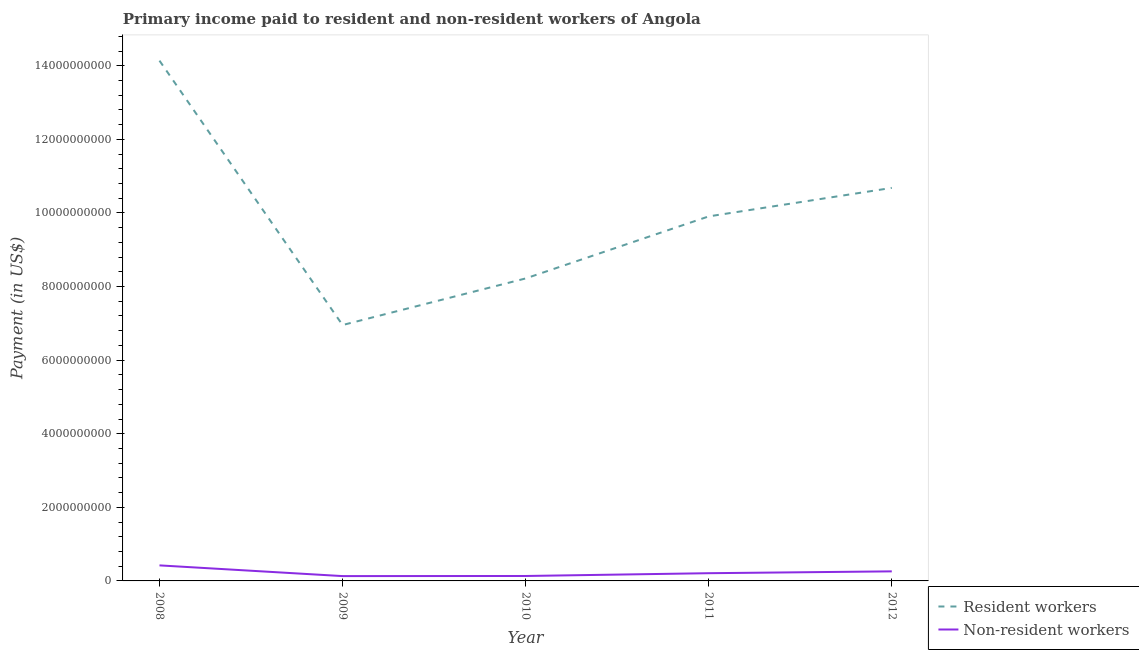How many different coloured lines are there?
Your answer should be very brief. 2. Does the line corresponding to payment made to resident workers intersect with the line corresponding to payment made to non-resident workers?
Make the answer very short. No. Is the number of lines equal to the number of legend labels?
Keep it short and to the point. Yes. What is the payment made to resident workers in 2011?
Give a very brief answer. 9.91e+09. Across all years, what is the maximum payment made to resident workers?
Provide a succinct answer. 1.41e+1. Across all years, what is the minimum payment made to non-resident workers?
Provide a short and direct response. 1.31e+08. In which year was the payment made to non-resident workers maximum?
Give a very brief answer. 2008. What is the total payment made to resident workers in the graph?
Keep it short and to the point. 4.99e+1. What is the difference between the payment made to resident workers in 2010 and that in 2012?
Your response must be concise. -2.46e+09. What is the difference between the payment made to resident workers in 2012 and the payment made to non-resident workers in 2008?
Provide a succinct answer. 1.03e+1. What is the average payment made to resident workers per year?
Provide a short and direct response. 9.98e+09. In the year 2008, what is the difference between the payment made to resident workers and payment made to non-resident workers?
Ensure brevity in your answer.  1.37e+1. In how many years, is the payment made to resident workers greater than 7600000000 US$?
Make the answer very short. 4. What is the ratio of the payment made to resident workers in 2008 to that in 2009?
Provide a short and direct response. 2.03. Is the difference between the payment made to non-resident workers in 2009 and 2012 greater than the difference between the payment made to resident workers in 2009 and 2012?
Your answer should be very brief. Yes. What is the difference between the highest and the second highest payment made to resident workers?
Keep it short and to the point. 3.46e+09. What is the difference between the highest and the lowest payment made to resident workers?
Ensure brevity in your answer.  7.19e+09. In how many years, is the payment made to resident workers greater than the average payment made to resident workers taken over all years?
Your response must be concise. 2. Is the sum of the payment made to non-resident workers in 2010 and 2011 greater than the maximum payment made to resident workers across all years?
Provide a succinct answer. No. What is the difference between two consecutive major ticks on the Y-axis?
Provide a succinct answer. 2.00e+09. Are the values on the major ticks of Y-axis written in scientific E-notation?
Provide a succinct answer. No. Does the graph contain grids?
Provide a short and direct response. No. Where does the legend appear in the graph?
Ensure brevity in your answer.  Bottom right. How are the legend labels stacked?
Provide a short and direct response. Vertical. What is the title of the graph?
Your answer should be very brief. Primary income paid to resident and non-resident workers of Angola. Does "Merchandise exports" appear as one of the legend labels in the graph?
Your response must be concise. No. What is the label or title of the X-axis?
Offer a very short reply. Year. What is the label or title of the Y-axis?
Offer a terse response. Payment (in US$). What is the Payment (in US$) of Resident workers in 2008?
Your answer should be compact. 1.41e+1. What is the Payment (in US$) in Non-resident workers in 2008?
Provide a succinct answer. 4.22e+08. What is the Payment (in US$) in Resident workers in 2009?
Provide a short and direct response. 6.95e+09. What is the Payment (in US$) in Non-resident workers in 2009?
Provide a short and direct response. 1.31e+08. What is the Payment (in US$) of Resident workers in 2010?
Your answer should be compact. 8.22e+09. What is the Payment (in US$) in Non-resident workers in 2010?
Offer a very short reply. 1.34e+08. What is the Payment (in US$) of Resident workers in 2011?
Ensure brevity in your answer.  9.91e+09. What is the Payment (in US$) in Non-resident workers in 2011?
Your answer should be very brief. 2.10e+08. What is the Payment (in US$) of Resident workers in 2012?
Keep it short and to the point. 1.07e+1. What is the Payment (in US$) of Non-resident workers in 2012?
Offer a very short reply. 2.60e+08. Across all years, what is the maximum Payment (in US$) of Resident workers?
Your response must be concise. 1.41e+1. Across all years, what is the maximum Payment (in US$) of Non-resident workers?
Provide a succinct answer. 4.22e+08. Across all years, what is the minimum Payment (in US$) of Resident workers?
Your answer should be very brief. 6.95e+09. Across all years, what is the minimum Payment (in US$) in Non-resident workers?
Offer a very short reply. 1.31e+08. What is the total Payment (in US$) of Resident workers in the graph?
Your answer should be very brief. 4.99e+1. What is the total Payment (in US$) in Non-resident workers in the graph?
Keep it short and to the point. 1.16e+09. What is the difference between the Payment (in US$) of Resident workers in 2008 and that in 2009?
Provide a succinct answer. 7.19e+09. What is the difference between the Payment (in US$) of Non-resident workers in 2008 and that in 2009?
Offer a terse response. 2.91e+08. What is the difference between the Payment (in US$) in Resident workers in 2008 and that in 2010?
Your response must be concise. 5.92e+09. What is the difference between the Payment (in US$) of Non-resident workers in 2008 and that in 2010?
Your response must be concise. 2.88e+08. What is the difference between the Payment (in US$) in Resident workers in 2008 and that in 2011?
Provide a short and direct response. 4.23e+09. What is the difference between the Payment (in US$) in Non-resident workers in 2008 and that in 2011?
Give a very brief answer. 2.12e+08. What is the difference between the Payment (in US$) in Resident workers in 2008 and that in 2012?
Give a very brief answer. 3.46e+09. What is the difference between the Payment (in US$) in Non-resident workers in 2008 and that in 2012?
Make the answer very short. 1.62e+08. What is the difference between the Payment (in US$) of Resident workers in 2009 and that in 2010?
Provide a succinct answer. -1.27e+09. What is the difference between the Payment (in US$) in Non-resident workers in 2009 and that in 2010?
Provide a short and direct response. -2.70e+06. What is the difference between the Payment (in US$) of Resident workers in 2009 and that in 2011?
Ensure brevity in your answer.  -2.95e+09. What is the difference between the Payment (in US$) in Non-resident workers in 2009 and that in 2011?
Make the answer very short. -7.85e+07. What is the difference between the Payment (in US$) of Resident workers in 2009 and that in 2012?
Offer a terse response. -3.73e+09. What is the difference between the Payment (in US$) in Non-resident workers in 2009 and that in 2012?
Give a very brief answer. -1.28e+08. What is the difference between the Payment (in US$) in Resident workers in 2010 and that in 2011?
Your response must be concise. -1.69e+09. What is the difference between the Payment (in US$) of Non-resident workers in 2010 and that in 2011?
Your answer should be very brief. -7.58e+07. What is the difference between the Payment (in US$) of Resident workers in 2010 and that in 2012?
Make the answer very short. -2.46e+09. What is the difference between the Payment (in US$) in Non-resident workers in 2010 and that in 2012?
Ensure brevity in your answer.  -1.26e+08. What is the difference between the Payment (in US$) in Resident workers in 2011 and that in 2012?
Your response must be concise. -7.74e+08. What is the difference between the Payment (in US$) in Non-resident workers in 2011 and that in 2012?
Offer a very short reply. -5.00e+07. What is the difference between the Payment (in US$) of Resident workers in 2008 and the Payment (in US$) of Non-resident workers in 2009?
Ensure brevity in your answer.  1.40e+1. What is the difference between the Payment (in US$) of Resident workers in 2008 and the Payment (in US$) of Non-resident workers in 2010?
Keep it short and to the point. 1.40e+1. What is the difference between the Payment (in US$) in Resident workers in 2008 and the Payment (in US$) in Non-resident workers in 2011?
Make the answer very short. 1.39e+1. What is the difference between the Payment (in US$) in Resident workers in 2008 and the Payment (in US$) in Non-resident workers in 2012?
Offer a terse response. 1.39e+1. What is the difference between the Payment (in US$) in Resident workers in 2009 and the Payment (in US$) in Non-resident workers in 2010?
Your answer should be compact. 6.82e+09. What is the difference between the Payment (in US$) in Resident workers in 2009 and the Payment (in US$) in Non-resident workers in 2011?
Your answer should be compact. 6.74e+09. What is the difference between the Payment (in US$) of Resident workers in 2009 and the Payment (in US$) of Non-resident workers in 2012?
Give a very brief answer. 6.69e+09. What is the difference between the Payment (in US$) of Resident workers in 2010 and the Payment (in US$) of Non-resident workers in 2011?
Offer a terse response. 8.01e+09. What is the difference between the Payment (in US$) of Resident workers in 2010 and the Payment (in US$) of Non-resident workers in 2012?
Offer a terse response. 7.96e+09. What is the difference between the Payment (in US$) in Resident workers in 2011 and the Payment (in US$) in Non-resident workers in 2012?
Make the answer very short. 9.65e+09. What is the average Payment (in US$) in Resident workers per year?
Ensure brevity in your answer.  9.98e+09. What is the average Payment (in US$) in Non-resident workers per year?
Provide a short and direct response. 2.31e+08. In the year 2008, what is the difference between the Payment (in US$) of Resident workers and Payment (in US$) of Non-resident workers?
Keep it short and to the point. 1.37e+1. In the year 2009, what is the difference between the Payment (in US$) of Resident workers and Payment (in US$) of Non-resident workers?
Ensure brevity in your answer.  6.82e+09. In the year 2010, what is the difference between the Payment (in US$) in Resident workers and Payment (in US$) in Non-resident workers?
Your response must be concise. 8.09e+09. In the year 2011, what is the difference between the Payment (in US$) in Resident workers and Payment (in US$) in Non-resident workers?
Offer a terse response. 9.70e+09. In the year 2012, what is the difference between the Payment (in US$) of Resident workers and Payment (in US$) of Non-resident workers?
Provide a short and direct response. 1.04e+1. What is the ratio of the Payment (in US$) of Resident workers in 2008 to that in 2009?
Offer a terse response. 2.03. What is the ratio of the Payment (in US$) of Non-resident workers in 2008 to that in 2009?
Keep it short and to the point. 3.22. What is the ratio of the Payment (in US$) in Resident workers in 2008 to that in 2010?
Your response must be concise. 1.72. What is the ratio of the Payment (in US$) in Non-resident workers in 2008 to that in 2010?
Keep it short and to the point. 3.15. What is the ratio of the Payment (in US$) of Resident workers in 2008 to that in 2011?
Make the answer very short. 1.43. What is the ratio of the Payment (in US$) in Non-resident workers in 2008 to that in 2011?
Provide a succinct answer. 2.01. What is the ratio of the Payment (in US$) in Resident workers in 2008 to that in 2012?
Keep it short and to the point. 1.32. What is the ratio of the Payment (in US$) of Non-resident workers in 2008 to that in 2012?
Your answer should be very brief. 1.63. What is the ratio of the Payment (in US$) in Resident workers in 2009 to that in 2010?
Make the answer very short. 0.85. What is the ratio of the Payment (in US$) of Non-resident workers in 2009 to that in 2010?
Offer a very short reply. 0.98. What is the ratio of the Payment (in US$) in Resident workers in 2009 to that in 2011?
Give a very brief answer. 0.7. What is the ratio of the Payment (in US$) of Non-resident workers in 2009 to that in 2011?
Ensure brevity in your answer.  0.63. What is the ratio of the Payment (in US$) in Resident workers in 2009 to that in 2012?
Your answer should be compact. 0.65. What is the ratio of the Payment (in US$) of Non-resident workers in 2009 to that in 2012?
Provide a succinct answer. 0.51. What is the ratio of the Payment (in US$) of Resident workers in 2010 to that in 2011?
Provide a short and direct response. 0.83. What is the ratio of the Payment (in US$) in Non-resident workers in 2010 to that in 2011?
Give a very brief answer. 0.64. What is the ratio of the Payment (in US$) in Resident workers in 2010 to that in 2012?
Your response must be concise. 0.77. What is the ratio of the Payment (in US$) in Non-resident workers in 2010 to that in 2012?
Offer a terse response. 0.52. What is the ratio of the Payment (in US$) in Resident workers in 2011 to that in 2012?
Give a very brief answer. 0.93. What is the ratio of the Payment (in US$) in Non-resident workers in 2011 to that in 2012?
Your response must be concise. 0.81. What is the difference between the highest and the second highest Payment (in US$) of Resident workers?
Make the answer very short. 3.46e+09. What is the difference between the highest and the second highest Payment (in US$) in Non-resident workers?
Your answer should be compact. 1.62e+08. What is the difference between the highest and the lowest Payment (in US$) in Resident workers?
Ensure brevity in your answer.  7.19e+09. What is the difference between the highest and the lowest Payment (in US$) in Non-resident workers?
Your response must be concise. 2.91e+08. 